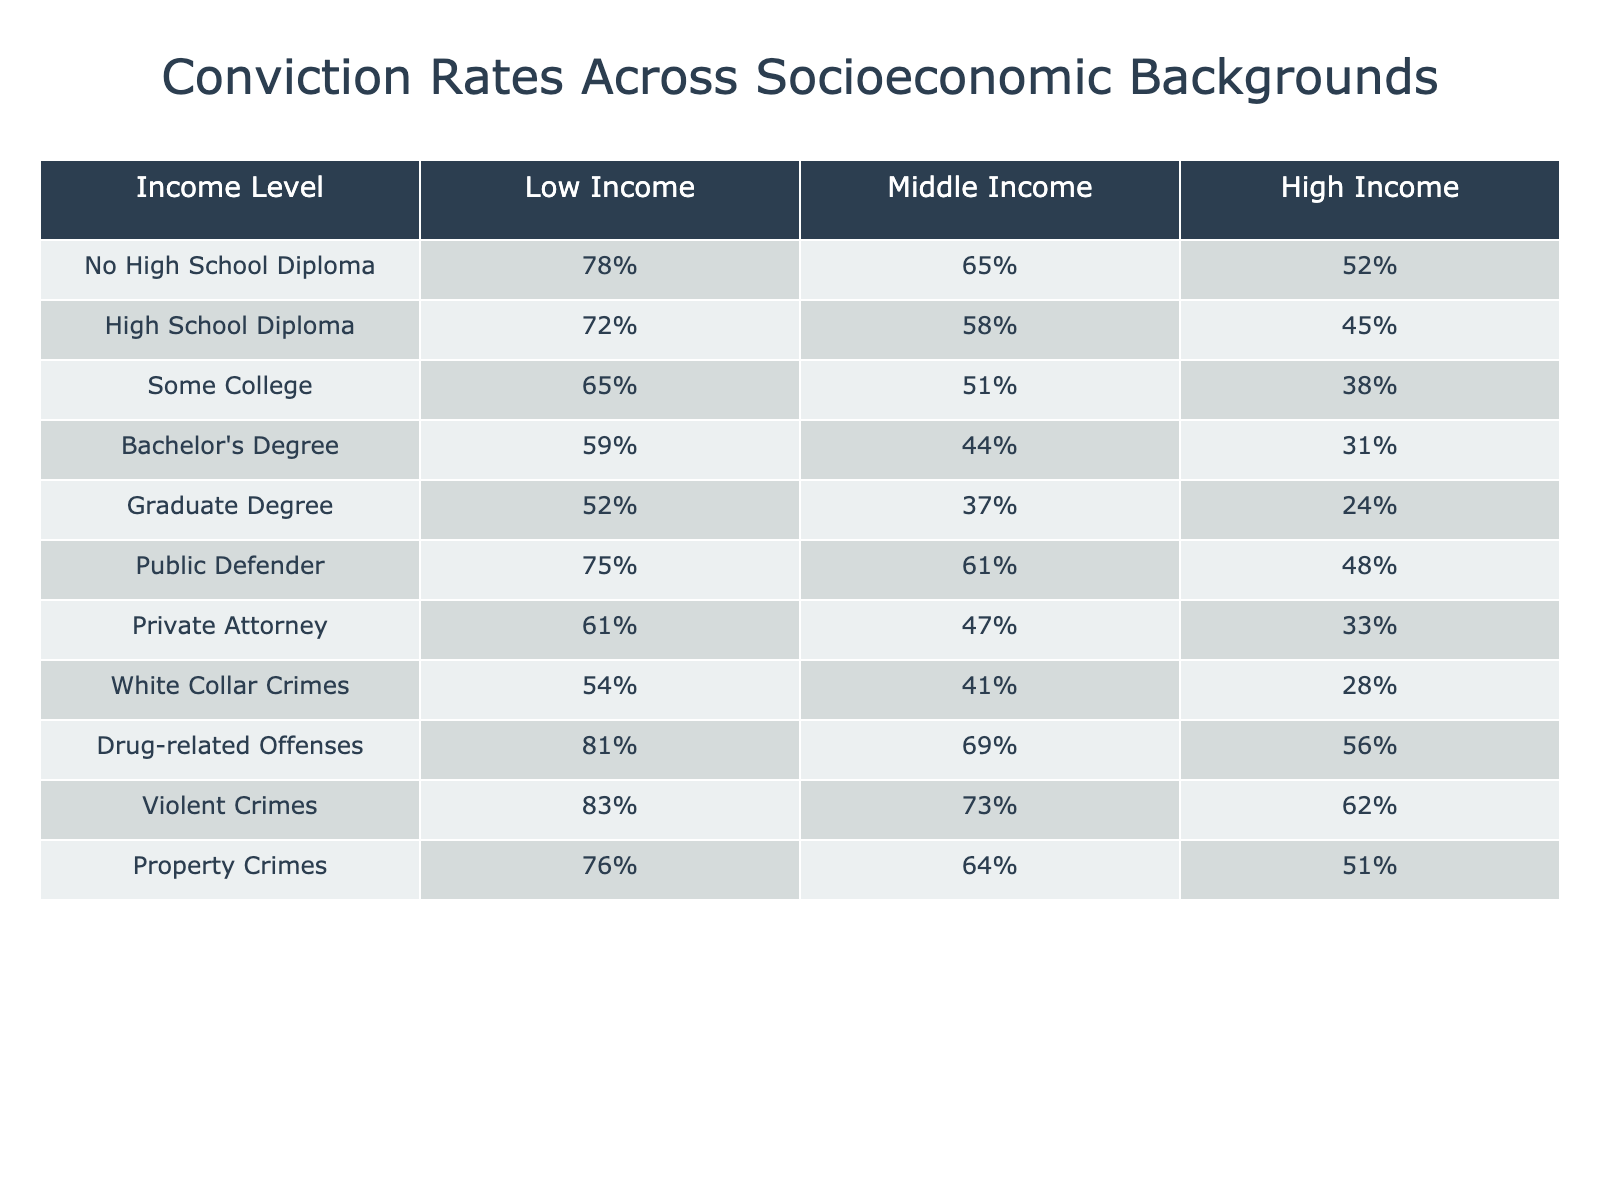What is the conviction rate for individuals with a Graduate Degree and a High Income? In the table, find the row for "Graduate Degree" and look under the "High Income" column. The conviction rate listed is 24%.
Answer: 24% Which income level has the highest conviction rate for Violent Crimes? Look at the "Violent Crimes" row and compare the conviction rates across the income levels. The highest rate is for Low Income, which is 83%.
Answer: 83% What is the difference in conviction rates between Low Income and High Income individuals for property crimes? From the "Property Crimes" row, the conviction rate for Low Income is 76% and for High Income it’s 51%. The difference is 76% - 51% = 25%.
Answer: 25% True or False: The conviction rate for Drug-related Offenses is higher for Middle Income compared to Low Income. Look at the "Drug-related Offenses" row. The rate for Low Income is 81% and for Middle Income is 69%. Since 81% is greater than 69%, the statement is false.
Answer: False Which educational level has the lowest conviction rate across all income levels? Review each row in the table for educational levels and find the lowest conviction rate. The "Graduate Degree" category has the lowest rate, which is 24% for High Income.
Answer: Graduate Degree What are the average conviction rates for Middle Income individuals across all educational levels? To find the average, add the conviction rates for Middle Income: 65% (No High School Diploma) + 58% (High School Diploma) + 51% (Some College) + 44% (Bachelor's Degree) + 37% (Graduate Degree) + 61% (Public Defender) + 47% (Private Attorney) + 41% (White Collar Crimes) + 69% (Drug-related Offenses) + 73% (Violent Crimes) + 64% (Property Crimes). This totals to 558%. Divide by the number of categories (11), giving an average of 50.73%.
Answer: 50.73% For which type of crime does the Low Income group have the highest conviction rate? Look at all the rows for Low Income and identify which crime has the highest conviction rate. The highest rate is for Drug-related Offenses at 81%.
Answer: Drug-related Offenses What is the trend in conviction rates as income level increases for individuals with a Bachelor's Degree? Analyzing the "Bachelor's Degree" row, we see conviction rates decrease as income rises: 59% (Low Income), 44% (Middle Income), 31% (High Income). This indicates a downward trend as income increases.
Answer: Downward trend 